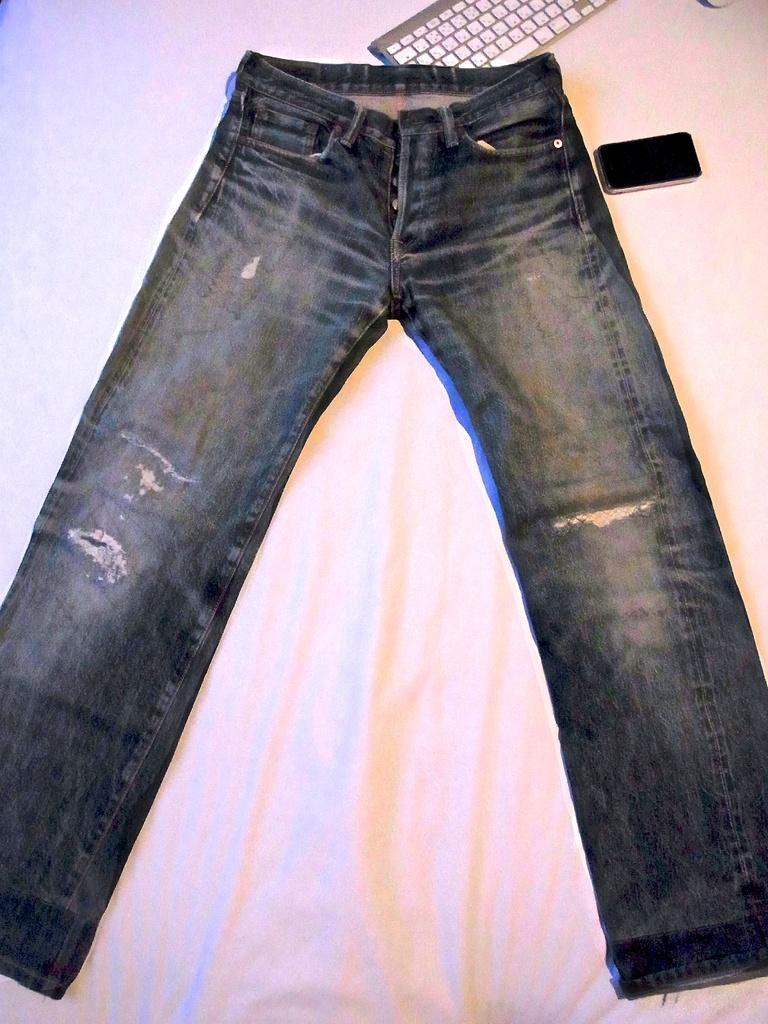What piece of furniture is present in the image? There is a bed in the image. What color is the bed sheet? The bed sheet is white in color. What type of clothing is on the bed? There are black color jeans on the bed. What electronic device is on the bed? There is a keyboard on the bed. What communication device is on the bed? There is a mobile phone on the bed. What type of oven is visible in the image? There is no oven present in the image. How does the bed affect the acoustics of the room in the image? The image does not provide information about the acoustics of the room, so it cannot be determined how the bed affects it. 